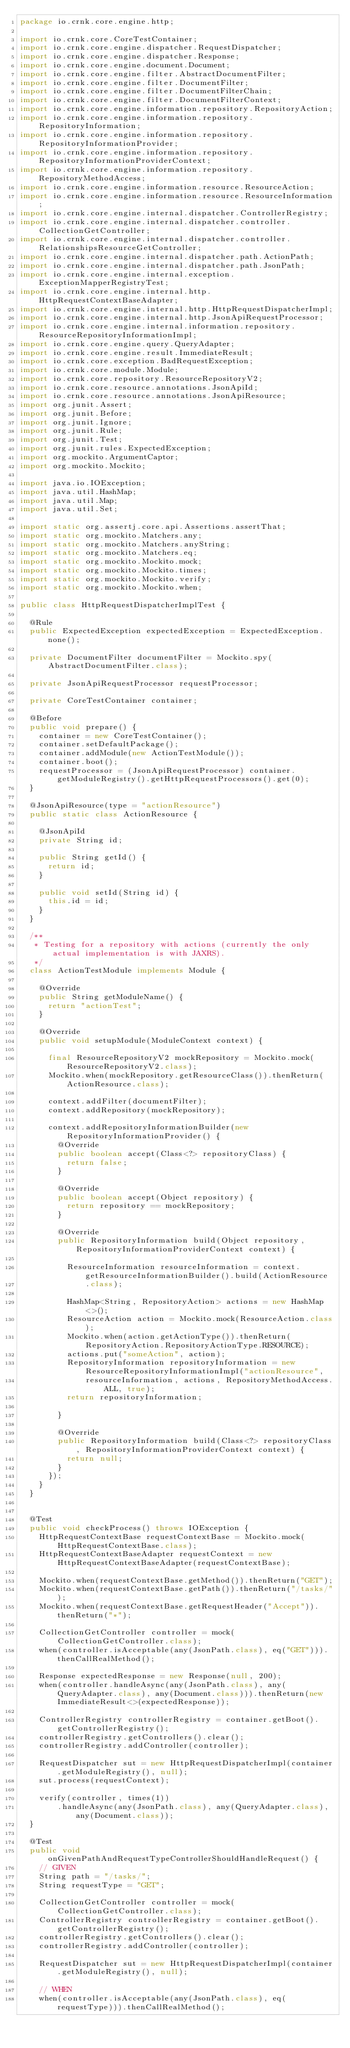<code> <loc_0><loc_0><loc_500><loc_500><_Java_>package io.crnk.core.engine.http;

import io.crnk.core.CoreTestContainer;
import io.crnk.core.engine.dispatcher.RequestDispatcher;
import io.crnk.core.engine.dispatcher.Response;
import io.crnk.core.engine.document.Document;
import io.crnk.core.engine.filter.AbstractDocumentFilter;
import io.crnk.core.engine.filter.DocumentFilter;
import io.crnk.core.engine.filter.DocumentFilterChain;
import io.crnk.core.engine.filter.DocumentFilterContext;
import io.crnk.core.engine.information.repository.RepositoryAction;
import io.crnk.core.engine.information.repository.RepositoryInformation;
import io.crnk.core.engine.information.repository.RepositoryInformationProvider;
import io.crnk.core.engine.information.repository.RepositoryInformationProviderContext;
import io.crnk.core.engine.information.repository.RepositoryMethodAccess;
import io.crnk.core.engine.information.resource.ResourceAction;
import io.crnk.core.engine.information.resource.ResourceInformation;
import io.crnk.core.engine.internal.dispatcher.ControllerRegistry;
import io.crnk.core.engine.internal.dispatcher.controller.CollectionGetController;
import io.crnk.core.engine.internal.dispatcher.controller.RelationshipsResourceGetController;
import io.crnk.core.engine.internal.dispatcher.path.ActionPath;
import io.crnk.core.engine.internal.dispatcher.path.JsonPath;
import io.crnk.core.engine.internal.exception.ExceptionMapperRegistryTest;
import io.crnk.core.engine.internal.http.HttpRequestContextBaseAdapter;
import io.crnk.core.engine.internal.http.HttpRequestDispatcherImpl;
import io.crnk.core.engine.internal.http.JsonApiRequestProcessor;
import io.crnk.core.engine.internal.information.repository.ResourceRepositoryInformationImpl;
import io.crnk.core.engine.query.QueryAdapter;
import io.crnk.core.engine.result.ImmediateResult;
import io.crnk.core.exception.BadRequestException;
import io.crnk.core.module.Module;
import io.crnk.core.repository.ResourceRepositoryV2;
import io.crnk.core.resource.annotations.JsonApiId;
import io.crnk.core.resource.annotations.JsonApiResource;
import org.junit.Assert;
import org.junit.Before;
import org.junit.Ignore;
import org.junit.Rule;
import org.junit.Test;
import org.junit.rules.ExpectedException;
import org.mockito.ArgumentCaptor;
import org.mockito.Mockito;

import java.io.IOException;
import java.util.HashMap;
import java.util.Map;
import java.util.Set;

import static org.assertj.core.api.Assertions.assertThat;
import static org.mockito.Matchers.any;
import static org.mockito.Matchers.anyString;
import static org.mockito.Matchers.eq;
import static org.mockito.Mockito.mock;
import static org.mockito.Mockito.times;
import static org.mockito.Mockito.verify;
import static org.mockito.Mockito.when;

public class HttpRequestDispatcherImplTest {

	@Rule
	public ExpectedException expectedException = ExpectedException.none();

	private DocumentFilter documentFilter = Mockito.spy(AbstractDocumentFilter.class);

	private JsonApiRequestProcessor requestProcessor;

	private CoreTestContainer container;

	@Before
	public void prepare() {
		container = new CoreTestContainer();
		container.setDefaultPackage();
		container.addModule(new ActionTestModule());
		container.boot();
		requestProcessor = (JsonApiRequestProcessor) container.getModuleRegistry().getHttpRequestProcessors().get(0);
	}

	@JsonApiResource(type = "actionResource")
	public static class ActionResource {

		@JsonApiId
		private String id;

		public String getId() {
			return id;
		}

		public void setId(String id) {
			this.id = id;
		}
	}

	/**
	 * Testing for a repository with actions (currently the only actual implementation is with JAXRS).
	 */
	class ActionTestModule implements Module {

		@Override
		public String getModuleName() {
			return "actionTest";
		}

		@Override
		public void setupModule(ModuleContext context) {

			final ResourceRepositoryV2 mockRepository = Mockito.mock(ResourceRepositoryV2.class);
			Mockito.when(mockRepository.getResourceClass()).thenReturn(ActionResource.class);

			context.addFilter(documentFilter);
			context.addRepository(mockRepository);

			context.addRepositoryInformationBuilder(new RepositoryInformationProvider() {
				@Override
				public boolean accept(Class<?> repositoryClass) {
					return false;
				}

				@Override
				public boolean accept(Object repository) {
					return repository == mockRepository;
				}

				@Override
				public RepositoryInformation build(Object repository, RepositoryInformationProviderContext context) {

					ResourceInformation resourceInformation = context.getResourceInformationBuilder().build(ActionResource
							.class);

					HashMap<String, RepositoryAction> actions = new HashMap<>();
					ResourceAction action = Mockito.mock(ResourceAction.class);
					Mockito.when(action.getActionType()).thenReturn(RepositoryAction.RepositoryActionType.RESOURCE);
					actions.put("someAction", action);
					RepositoryInformation repositoryInformation = new ResourceRepositoryInformationImpl("actionResource",
							resourceInformation, actions, RepositoryMethodAccess.ALL, true);
					return repositoryInformation;

				}

				@Override
				public RepositoryInformation build(Class<?> repositoryClass, RepositoryInformationProviderContext context) {
					return null;
				}
			});
		}
	}


	@Test
	public void checkProcess() throws IOException {
		HttpRequestContextBase requestContextBase = Mockito.mock(HttpRequestContextBase.class);
		HttpRequestContextBaseAdapter requestContext = new HttpRequestContextBaseAdapter(requestContextBase);

		Mockito.when(requestContextBase.getMethod()).thenReturn("GET");
		Mockito.when(requestContextBase.getPath()).thenReturn("/tasks/");
		Mockito.when(requestContextBase.getRequestHeader("Accept")).thenReturn("*");

		CollectionGetController controller = mock(CollectionGetController.class);
		when(controller.isAcceptable(any(JsonPath.class), eq("GET"))).thenCallRealMethod();

		Response expectedResponse = new Response(null, 200);
		when(controller.handleAsync(any(JsonPath.class), any(QueryAdapter.class), any(Document.class))).thenReturn(new ImmediateResult<>(expectedResponse));

		ControllerRegistry controllerRegistry = container.getBoot().getControllerRegistry();
		controllerRegistry.getControllers().clear();
		controllerRegistry.addController(controller);

		RequestDispatcher sut = new HttpRequestDispatcherImpl(container.getModuleRegistry(), null);
		sut.process(requestContext);

		verify(controller, times(1))
				.handleAsync(any(JsonPath.class), any(QueryAdapter.class), any(Document.class));
	}

	@Test
	public void onGivenPathAndRequestTypeControllerShouldHandleRequest() {
		// GIVEN
		String path = "/tasks/";
		String requestType = "GET";

		CollectionGetController controller = mock(CollectionGetController.class);
		ControllerRegistry controllerRegistry = container.getBoot().getControllerRegistry();
		controllerRegistry.getControllers().clear();
		controllerRegistry.addController(controller);

		RequestDispatcher sut = new HttpRequestDispatcherImpl(container.getModuleRegistry(), null);

		// WHEN
		when(controller.isAcceptable(any(JsonPath.class), eq(requestType))).thenCallRealMethod();</code> 